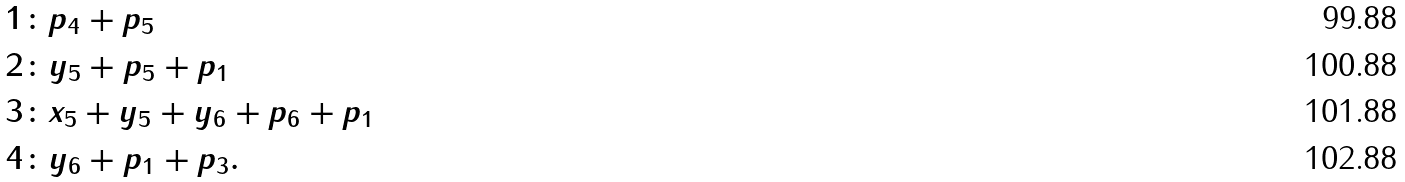Convert formula to latex. <formula><loc_0><loc_0><loc_500><loc_500>1 \colon & p _ { 4 } + p _ { 5 } \\ 2 \colon & y _ { 5 } + p _ { 5 } + p _ { 1 } \\ 3 \colon & x _ { 5 } + y _ { 5 } + y _ { 6 } + p _ { 6 } + p _ { 1 } \\ 4 \colon & y _ { 6 } + p _ { 1 } + p _ { 3 } .</formula> 